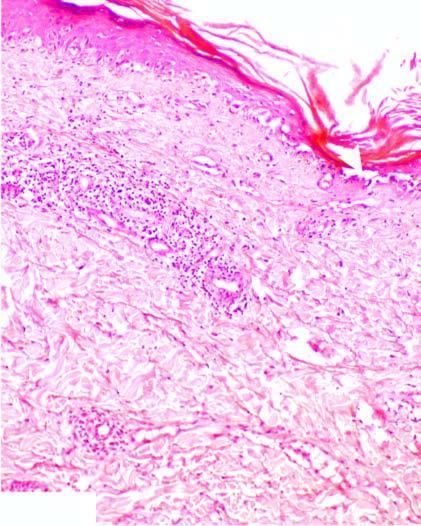what shows hydropic degeneration and loss of dermoepidermal junction?
Answer the question using a single word or phrase. Basal layer 